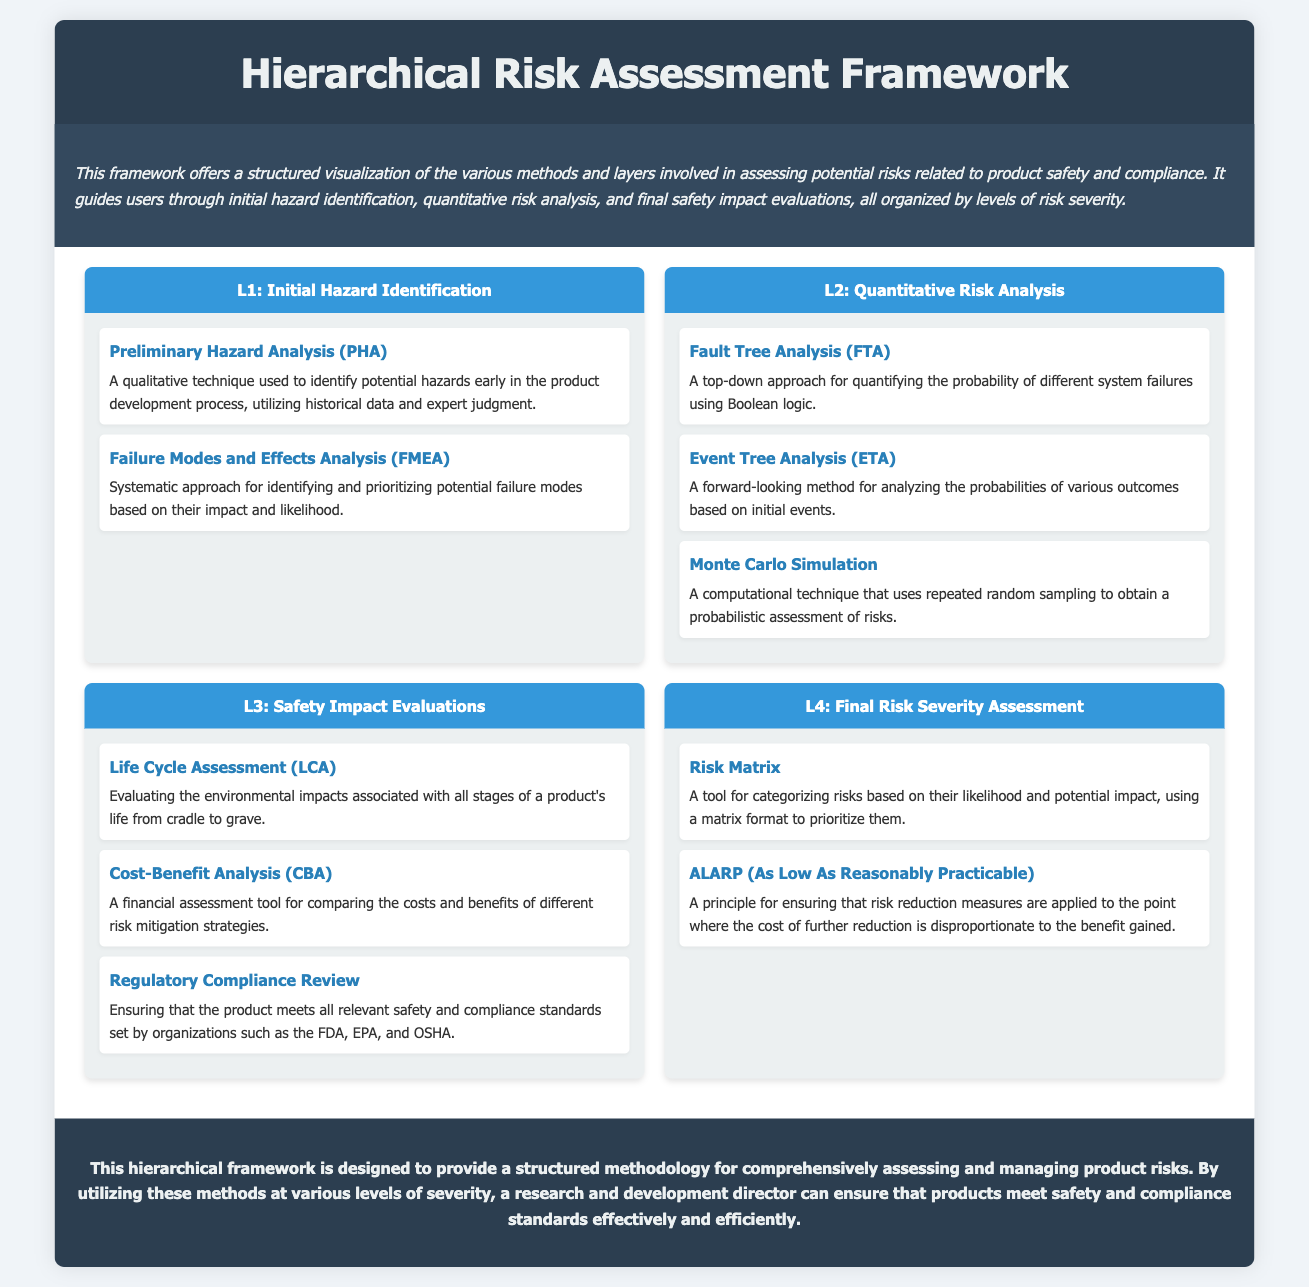What is the title of the framework? The title of the framework is displayed prominently at the top of the document.
Answer: Hierarchical Risk Assessment Framework How many levels are there in the framework? The document outlines four distinct levels of risk assessment methods.
Answer: Four What is the first method listed under Level 1? The first method listed under Level 1 is the first in the list of techniques related to hazard identification.
Answer: Preliminary Hazard Analysis (PHA) Which method in Level 2 uses Boolean logic? This method quantifies the probability of different system failures.
Answer: Fault Tree Analysis (FTA) What does ALARP stand for? This principle is essential for ensuring risk reduction measures are applied as practicable.
Answer: As Low As Reasonably Practicable What is the main focus of the Life Cycle Assessment? This evaluation considers the impacts throughout the product’s existence.
Answer: Environmental impacts Which level contains the method for regulatory compliance review? The method is crucial for ensuring adherence to safety standards.
Answer: Level 3 What is the primary purpose of the Risk Matrix? This tool categorizes risks based on specific criteria of likelihood and impact.
Answer: To categorize risks How is the conclusion section characterized in the document? The conclusion summarizes the intent and effectiveness of the framework.
Answer: Structured methodology 